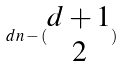<formula> <loc_0><loc_0><loc_500><loc_500>d n - ( \begin{matrix} d + 1 \\ 2 \end{matrix} )</formula> 